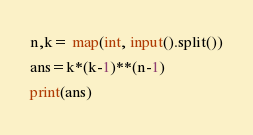<code> <loc_0><loc_0><loc_500><loc_500><_Python_>n,k= map(int, input().split())
ans=k*(k-1)**(n-1)
print(ans)</code> 